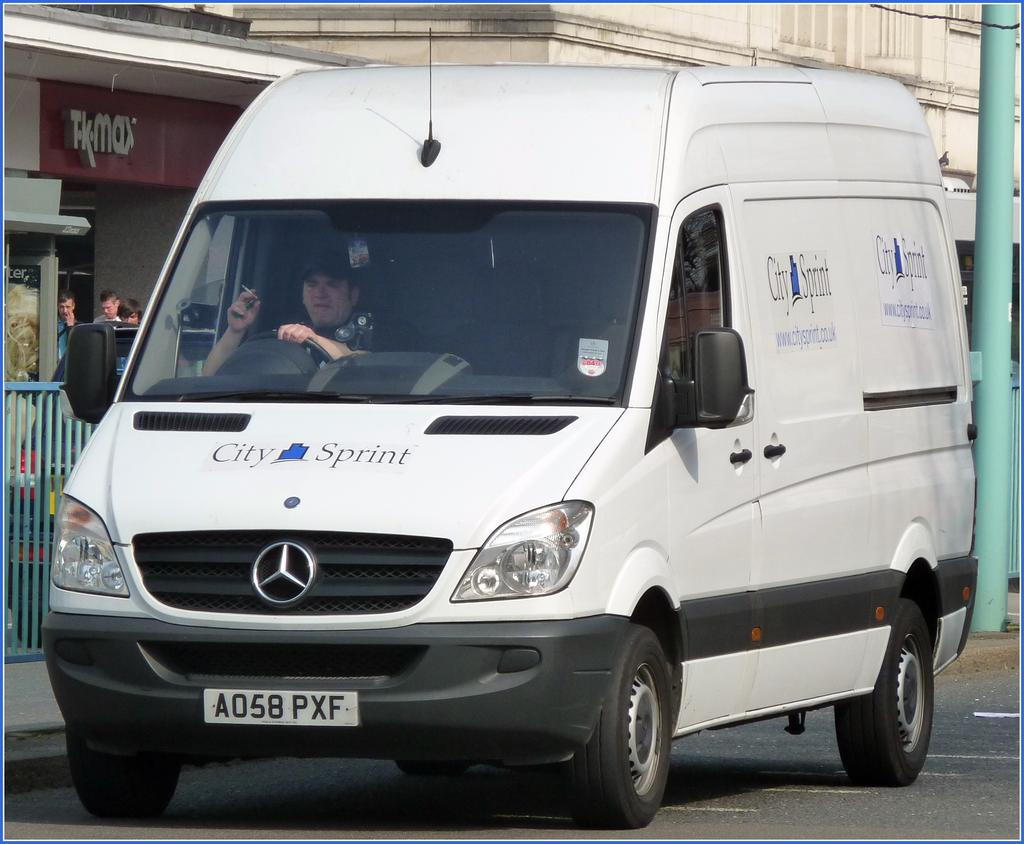<image>
Create a compact narrative representing the image presented. A white City Sprint van is pulled up along a curb in front of a TK Max store. 